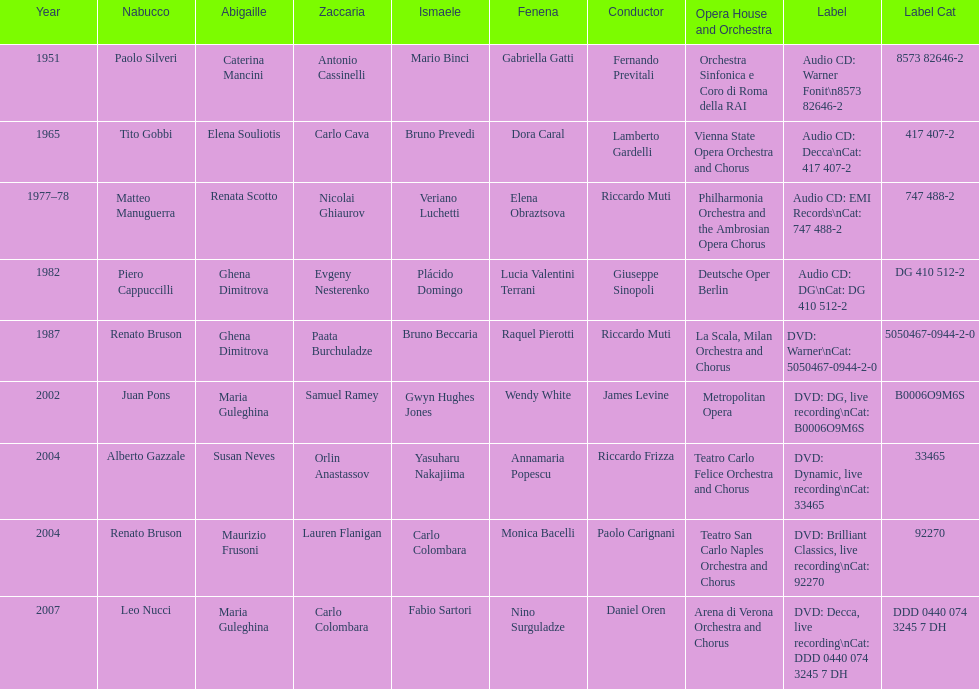When was the recording of nabucco made in the metropolitan opera? 2002. 